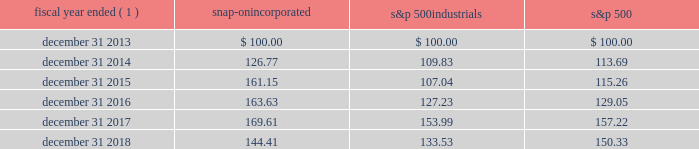2018 annual report 23 five-year stock performance graph the graph below illustrates the cumulative total shareholder return on snap-on common stock since december 31 , 2013 , of a $ 100 investment , assuming that dividends were reinvested quarterly .
The graph compares snap-on 2019s performance to that of the standard & poor 2019s 500 industrials index ( 201cs&p 500 industrials 201d ) and standard & poor 2019s 500 stock index ( 201cs&p 500 201d ) .
Fiscal year ended ( 1 ) snap-on incorporated s&p 500 industrials s&p 500 .
( 1 ) the company 2019s fiscal year ends on the saturday that is on or nearest to december 31 of each year ; for ease of calculation , the fiscal year end is assumed to be december 31. .
What was the percent change in the snap-on performance from 2015 to 2016? 
Computations: (163.63 - 126.77)
Answer: 36.86. 